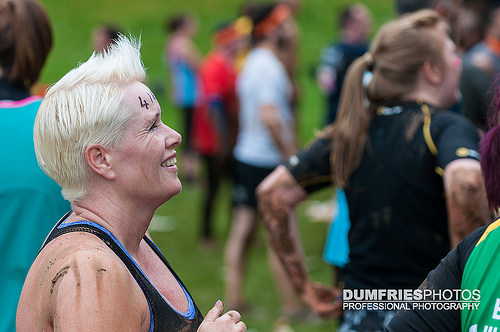<image>
Is there a man behind the woman? No. The man is not behind the woman. From this viewpoint, the man appears to be positioned elsewhere in the scene. 